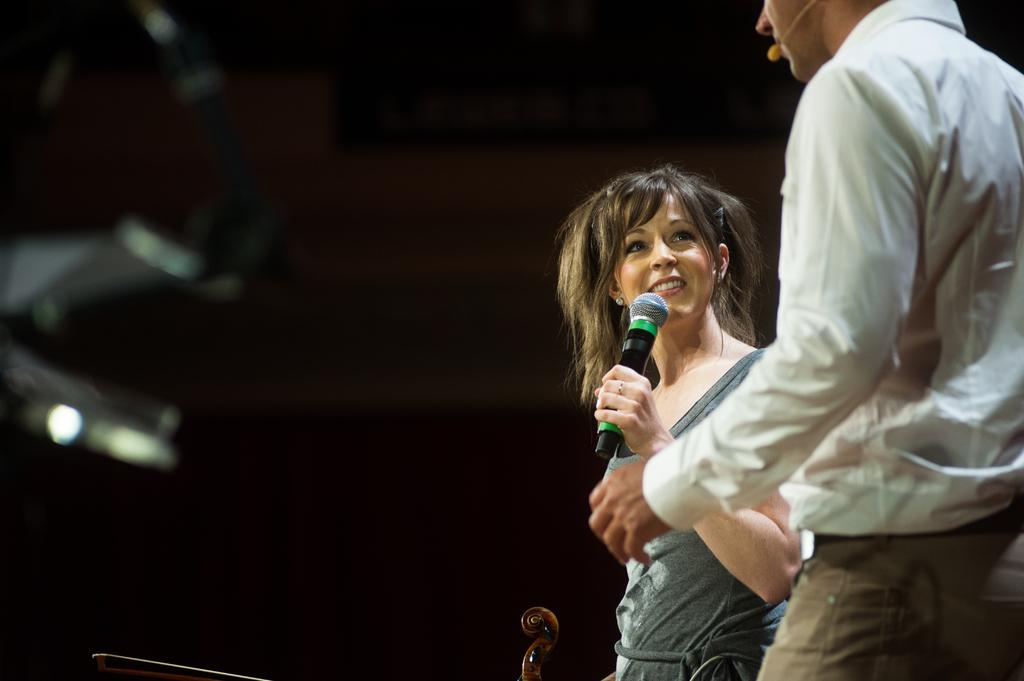What is the gender of the person in the image? There is a woman in the image. What is the woman doing in the image? The woman is standing and smiling. What object is the woman holding in her hand? The woman is holding a microphone in her hand. Can you describe the man in the image? The man is wearing a white shirt and brown color pants. What is the man holding in the image? The man is holding a microphone. What type of poison is visible in the image? There is no poison present in the image. Can you tell me how many units are visible in the image? There is no reference to any units in the image. 